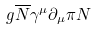<formula> <loc_0><loc_0><loc_500><loc_500>g \overline { N } \gamma ^ { \mu } \partial _ { \mu } \pi N</formula> 